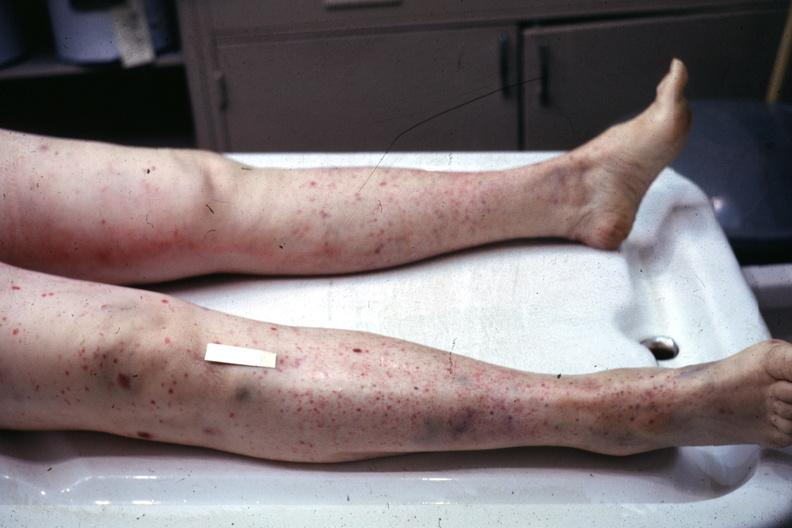what is present?
Answer the question using a single word or phrase. Leg 